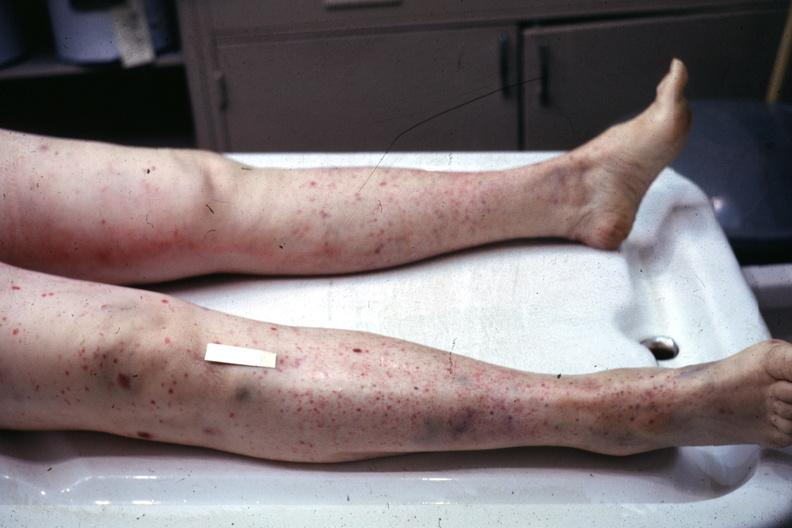what is present?
Answer the question using a single word or phrase. Leg 